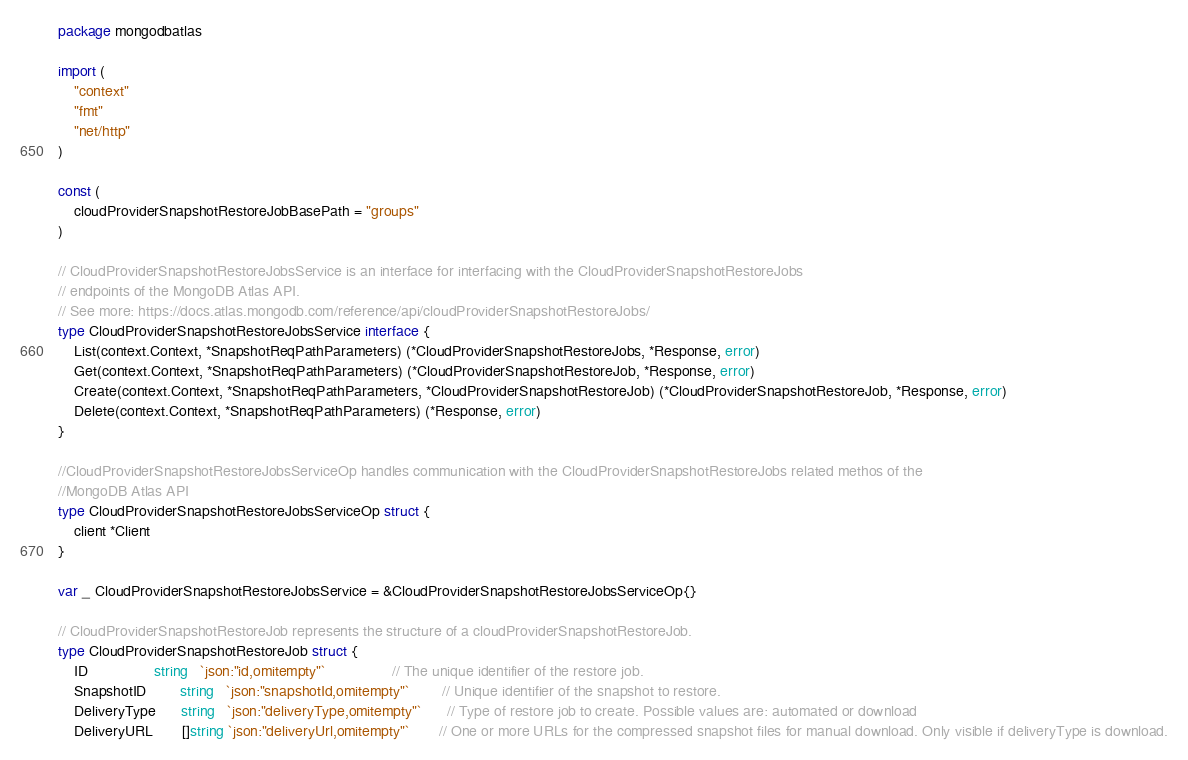Convert code to text. <code><loc_0><loc_0><loc_500><loc_500><_Go_>package mongodbatlas

import (
	"context"
	"fmt"
	"net/http"
)

const (
	cloudProviderSnapshotRestoreJobBasePath = "groups"
)

// CloudProviderSnapshotRestoreJobsService is an interface for interfacing with the CloudProviderSnapshotRestoreJobs
// endpoints of the MongoDB Atlas API.
// See more: https://docs.atlas.mongodb.com/reference/api/cloudProviderSnapshotRestoreJobs/
type CloudProviderSnapshotRestoreJobsService interface {
	List(context.Context, *SnapshotReqPathParameters) (*CloudProviderSnapshotRestoreJobs, *Response, error)
	Get(context.Context, *SnapshotReqPathParameters) (*CloudProviderSnapshotRestoreJob, *Response, error)
	Create(context.Context, *SnapshotReqPathParameters, *CloudProviderSnapshotRestoreJob) (*CloudProviderSnapshotRestoreJob, *Response, error)
	Delete(context.Context, *SnapshotReqPathParameters) (*Response, error)
}

//CloudProviderSnapshotRestoreJobsServiceOp handles communication with the CloudProviderSnapshotRestoreJobs related methos of the
//MongoDB Atlas API
type CloudProviderSnapshotRestoreJobsServiceOp struct {
	client *Client
}

var _ CloudProviderSnapshotRestoreJobsService = &CloudProviderSnapshotRestoreJobsServiceOp{}

// CloudProviderSnapshotRestoreJob represents the structure of a cloudProviderSnapshotRestoreJob.
type CloudProviderSnapshotRestoreJob struct {
	ID                string   `json:"id,omitempty"`                // The unique identifier of the restore job.
	SnapshotID        string   `json:"snapshotId,omitempty"`        // Unique identifier of the snapshot to restore.
	DeliveryType      string   `json:"deliveryType,omitempty"`      // Type of restore job to create. Possible values are: automated or download
	DeliveryURL       []string `json:"deliveryUrl,omitempty"`       // One or more URLs for the compressed snapshot files for manual download. Only visible if deliveryType is download.</code> 